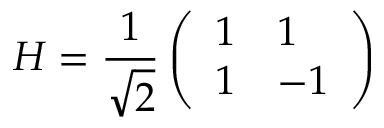<formula> <loc_0><loc_0><loc_500><loc_500>H = \frac { 1 } { \sqrt { 2 } } \left ( \begin{array} { l l } { 1 } & { 1 } \\ { 1 } & { - 1 } \end{array} \right )</formula> 